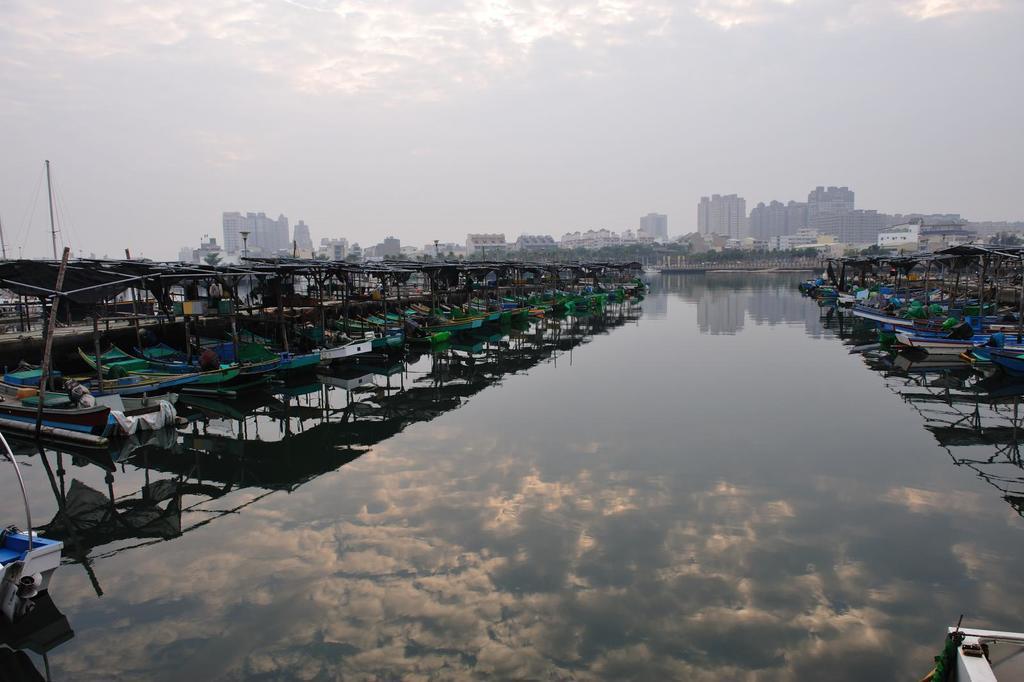In one or two sentences, can you explain what this image depicts? In this image I can see many boats are on the water. These boots are colorful. In the background I can see many trees, buildings, clouds and the sky. 